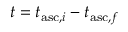Convert formula to latex. <formula><loc_0><loc_0><loc_500><loc_500>t = t _ { a s c , i } - t _ { a s c , f }</formula> 